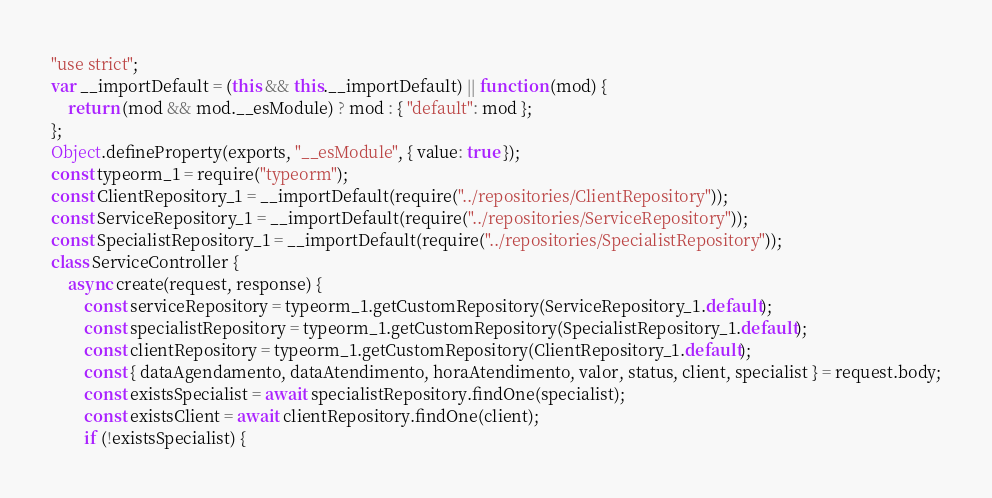<code> <loc_0><loc_0><loc_500><loc_500><_JavaScript_>"use strict";
var __importDefault = (this && this.__importDefault) || function (mod) {
    return (mod && mod.__esModule) ? mod : { "default": mod };
};
Object.defineProperty(exports, "__esModule", { value: true });
const typeorm_1 = require("typeorm");
const ClientRepository_1 = __importDefault(require("../repositories/ClientRepository"));
const ServiceRepository_1 = __importDefault(require("../repositories/ServiceRepository"));
const SpecialistRepository_1 = __importDefault(require("../repositories/SpecialistRepository"));
class ServiceController {
    async create(request, response) {
        const serviceRepository = typeorm_1.getCustomRepository(ServiceRepository_1.default);
        const specialistRepository = typeorm_1.getCustomRepository(SpecialistRepository_1.default);
        const clientRepository = typeorm_1.getCustomRepository(ClientRepository_1.default);
        const { dataAgendamento, dataAtendimento, horaAtendimento, valor, status, client, specialist } = request.body;
        const existsSpecialist = await specialistRepository.findOne(specialist);
        const existsClient = await clientRepository.findOne(client);
        if (!existsSpecialist) {</code> 